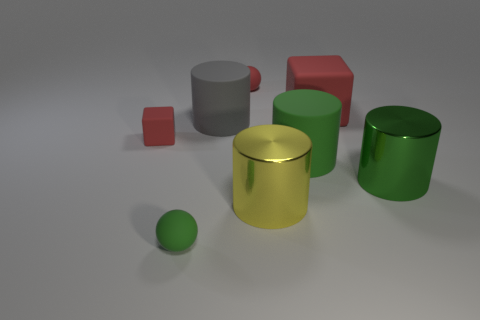Subtract all big yellow shiny cylinders. How many cylinders are left? 3 Subtract all blue spheres. How many green cylinders are left? 2 Add 1 tiny red cylinders. How many objects exist? 9 Subtract all red spheres. How many spheres are left? 1 Subtract 1 cylinders. How many cylinders are left? 3 Subtract all blocks. How many objects are left? 6 Subtract all blue cylinders. Subtract all cyan balls. How many cylinders are left? 4 Subtract all matte cubes. Subtract all rubber cylinders. How many objects are left? 4 Add 7 yellow cylinders. How many yellow cylinders are left? 8 Add 1 tiny objects. How many tiny objects exist? 4 